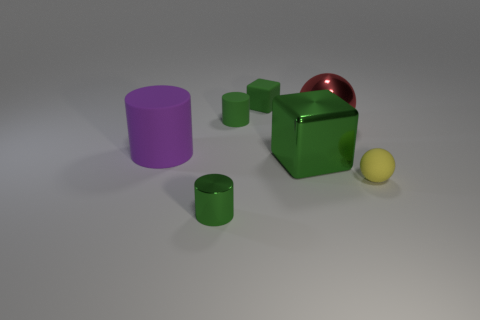Add 2 blue rubber cubes. How many objects exist? 9 Subtract all small green metal cylinders. How many cylinders are left? 2 Subtract all purple cylinders. How many cylinders are left? 2 Subtract 1 spheres. How many spheres are left? 1 Subtract all balls. How many objects are left? 5 Subtract all blue balls. Subtract all purple blocks. How many balls are left? 2 Subtract all purple cylinders. How many cyan balls are left? 0 Subtract all yellow blocks. Subtract all large green metal cubes. How many objects are left? 6 Add 7 big green objects. How many big green objects are left? 8 Add 1 big green blocks. How many big green blocks exist? 2 